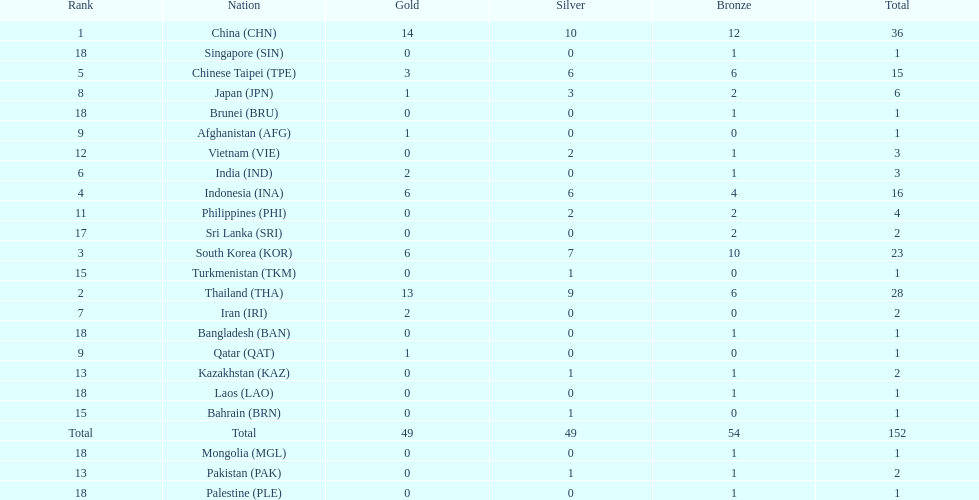What is the total number of nations that participated in the beach games of 2012? 23. 